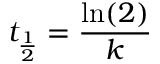Convert formula to latex. <formula><loc_0><loc_0><loc_500><loc_500>t _ { \frac { 1 } { 2 } } = { \frac { \ln ( 2 ) } { k } }</formula> 